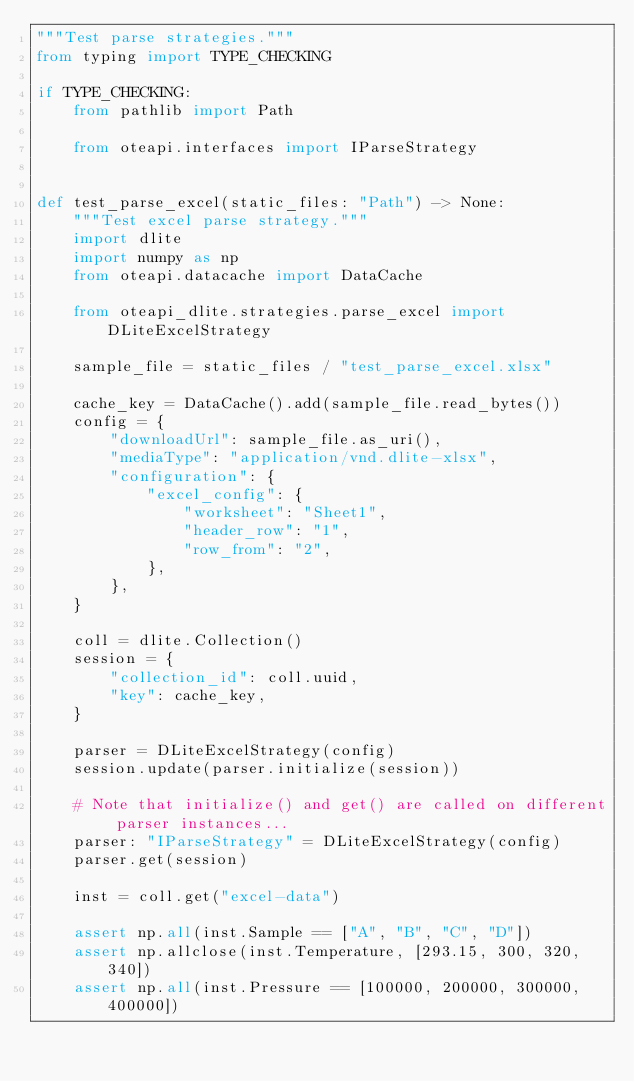Convert code to text. <code><loc_0><loc_0><loc_500><loc_500><_Python_>"""Test parse strategies."""
from typing import TYPE_CHECKING

if TYPE_CHECKING:
    from pathlib import Path

    from oteapi.interfaces import IParseStrategy


def test_parse_excel(static_files: "Path") -> None:
    """Test excel parse strategy."""
    import dlite
    import numpy as np
    from oteapi.datacache import DataCache

    from oteapi_dlite.strategies.parse_excel import DLiteExcelStrategy

    sample_file = static_files / "test_parse_excel.xlsx"

    cache_key = DataCache().add(sample_file.read_bytes())
    config = {
        "downloadUrl": sample_file.as_uri(),
        "mediaType": "application/vnd.dlite-xlsx",
        "configuration": {
            "excel_config": {
                "worksheet": "Sheet1",
                "header_row": "1",
                "row_from": "2",
            },
        },
    }

    coll = dlite.Collection()
    session = {
        "collection_id": coll.uuid,
        "key": cache_key,
    }

    parser = DLiteExcelStrategy(config)
    session.update(parser.initialize(session))

    # Note that initialize() and get() are called on different parser instances...
    parser: "IParseStrategy" = DLiteExcelStrategy(config)
    parser.get(session)

    inst = coll.get("excel-data")

    assert np.all(inst.Sample == ["A", "B", "C", "D"])
    assert np.allclose(inst.Temperature, [293.15, 300, 320, 340])
    assert np.all(inst.Pressure == [100000, 200000, 300000, 400000])
</code> 